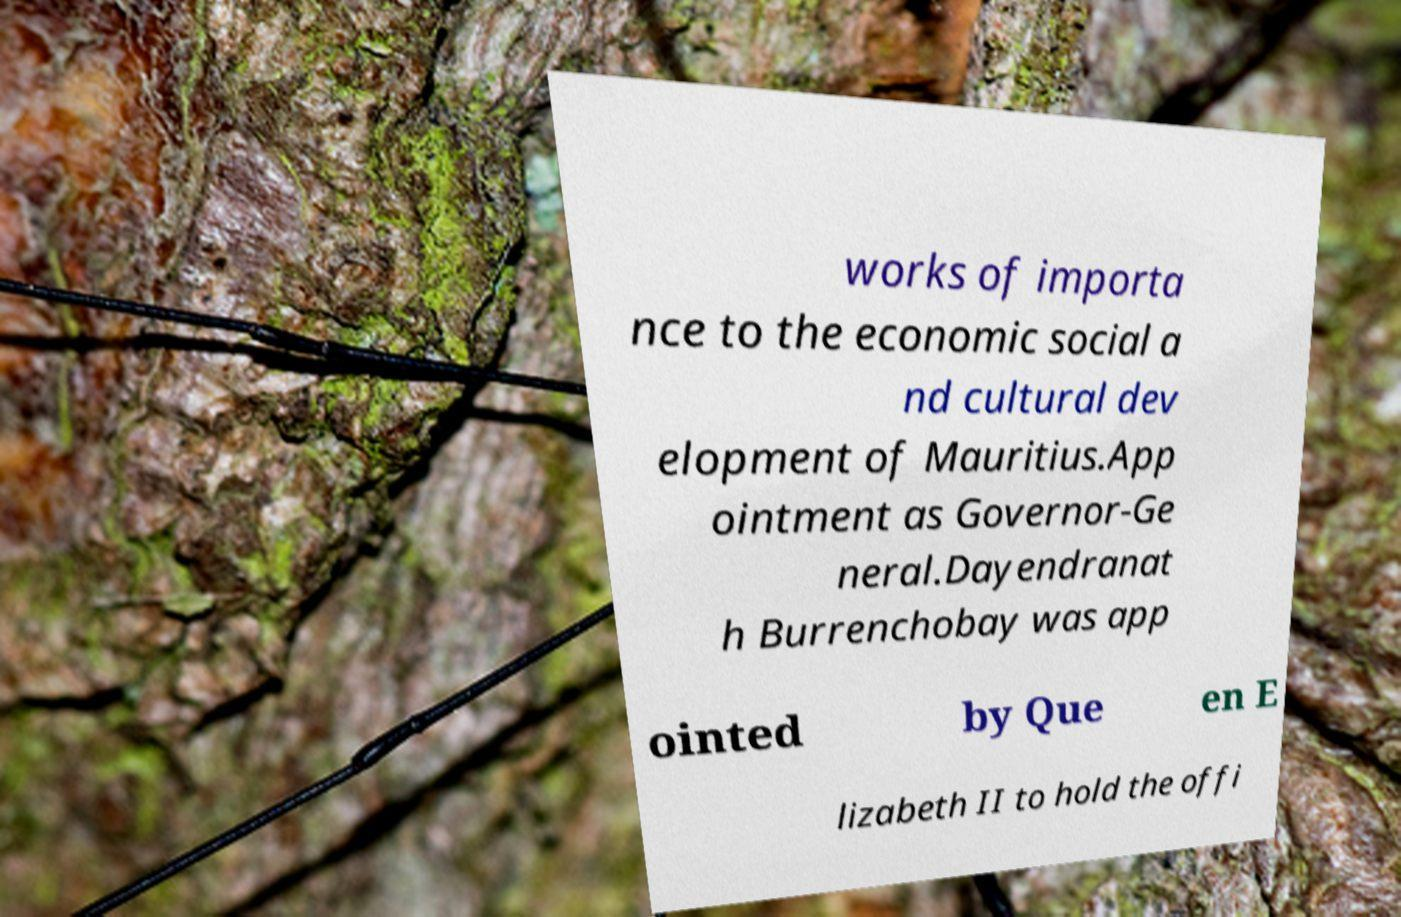I need the written content from this picture converted into text. Can you do that? works of importa nce to the economic social a nd cultural dev elopment of Mauritius.App ointment as Governor-Ge neral.Dayendranat h Burrenchobay was app ointed by Que en E lizabeth II to hold the offi 